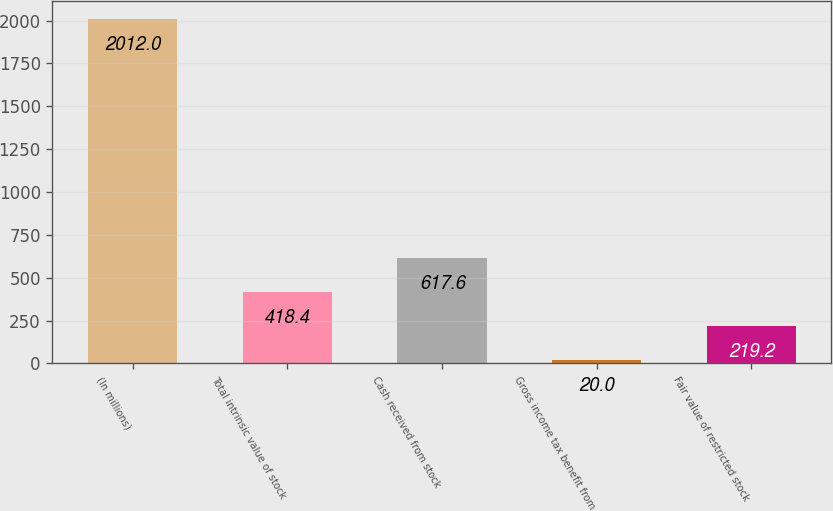Convert chart to OTSL. <chart><loc_0><loc_0><loc_500><loc_500><bar_chart><fcel>(In millions)<fcel>Total intrinsic value of stock<fcel>Cash received from stock<fcel>Gross income tax benefit from<fcel>Fair value of restricted stock<nl><fcel>2012<fcel>418.4<fcel>617.6<fcel>20<fcel>219.2<nl></chart> 